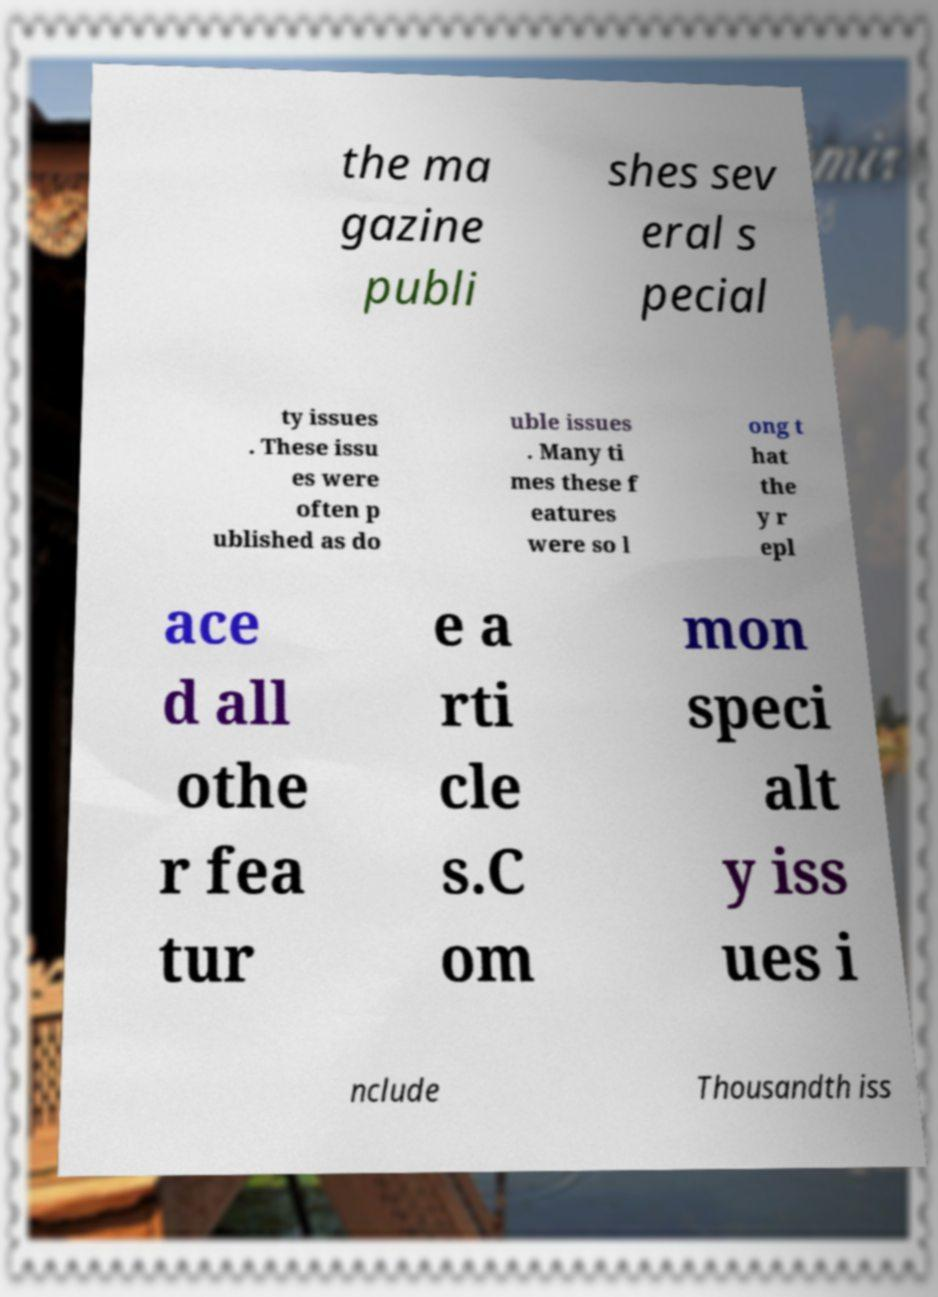For documentation purposes, I need the text within this image transcribed. Could you provide that? the ma gazine publi shes sev eral s pecial ty issues . These issu es were often p ublished as do uble issues . Many ti mes these f eatures were so l ong t hat the y r epl ace d all othe r fea tur e a rti cle s.C om mon speci alt y iss ues i nclude Thousandth iss 